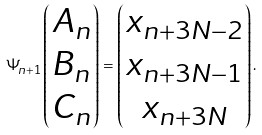<formula> <loc_0><loc_0><loc_500><loc_500>\Psi _ { n + 1 } \begin{pmatrix} A _ { n } \\ B _ { n } \\ C _ { n } \end{pmatrix} = \begin{pmatrix} x _ { n + 3 N - 2 } \\ x _ { n + 3 N - 1 } \\ x _ { n + 3 N } \end{pmatrix} .</formula> 